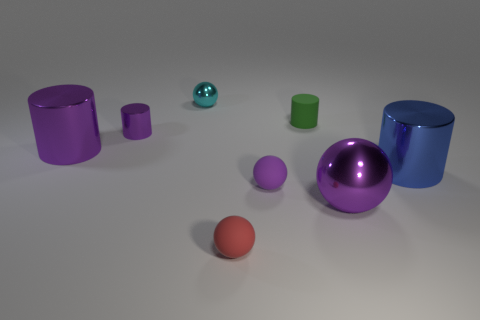What size is the rubber thing that is the same shape as the blue shiny object?
Provide a succinct answer. Small. What is the size of the rubber thing that is the same color as the tiny metal cylinder?
Give a very brief answer. Small. The other matte object that is the same shape as the tiny purple matte object is what color?
Ensure brevity in your answer.  Red. How many tiny things are the same color as the large sphere?
Provide a short and direct response. 2. Do the tiny metallic sphere and the large ball have the same color?
Give a very brief answer. No. There is a large cylinder that is to the right of the purple rubber thing; what material is it?
Your response must be concise. Metal. How many big objects are blue things or green rubber cylinders?
Provide a succinct answer. 1. There is a big ball that is the same color as the tiny metallic cylinder; what material is it?
Your response must be concise. Metal. Is there a cyan object that has the same material as the small green cylinder?
Provide a succinct answer. No. There is a sphere behind the blue metal cylinder; is it the same size as the red sphere?
Provide a succinct answer. Yes. 